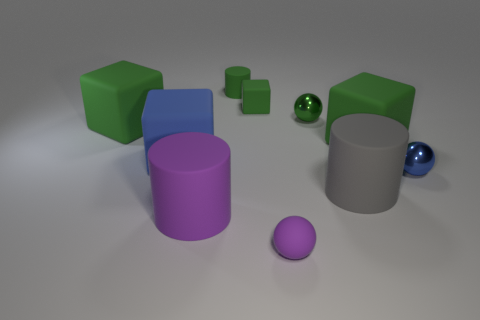There is a large cylinder that is left of the green shiny thing; is its color the same as the tiny matte ball?
Offer a very short reply. Yes. How big is the matte cylinder that is behind the tiny object on the right side of the tiny green shiny ball?
Provide a short and direct response. Small. What is the material of the tiny blue thing that is the same shape as the small green metallic thing?
Your response must be concise. Metal. What number of tiny cyan rubber objects are there?
Offer a very short reply. 0. There is a block right of the green matte cube that is behind the large green object that is left of the small purple rubber sphere; what is its color?
Your answer should be compact. Green. Is the number of things less than the number of small balls?
Offer a very short reply. No. There is another tiny shiny thing that is the same shape as the tiny blue metal object; what color is it?
Make the answer very short. Green. What is the color of the tiny cylinder that is made of the same material as the large blue cube?
Provide a short and direct response. Green. What number of green spheres are the same size as the purple matte ball?
Your answer should be compact. 1. What is the small blue thing made of?
Your response must be concise. Metal. 